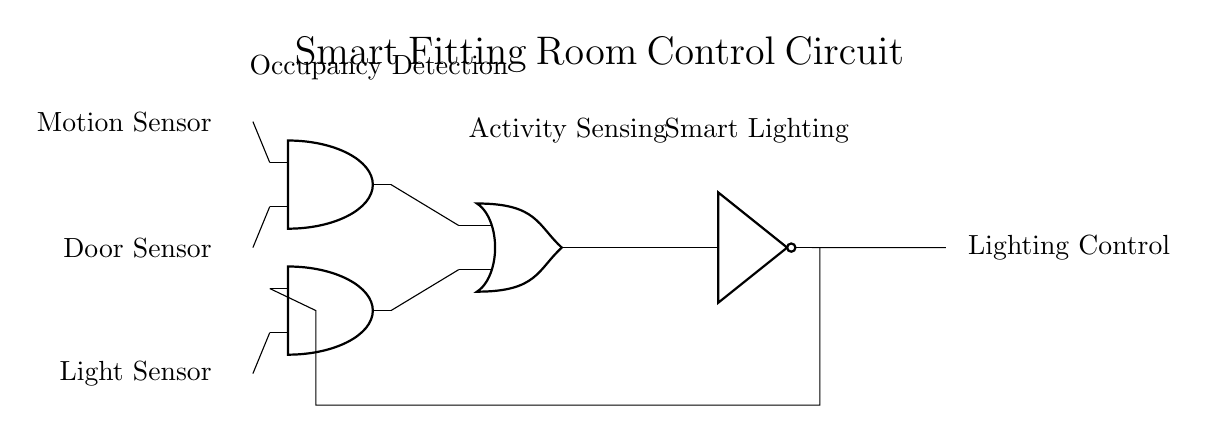What types of sensors are utilized in this circuit? The circuit uses three types of sensors: a motion sensor, a door sensor, and a light sensor, as indicated by their respective labels on the left side of the diagram.
Answer: motion sensor, door sensor, light sensor What component processes the signals from the motion and door sensors? The AND gate labeled as "Occupancy Detection" processes the inputs from both the motion sensor and the door sensor by combining their signals to determine if occupancy is detected.
Answer: AND gate How many AND gates are present in the circuit? There are two AND gates in the circuit, as seen in the diagram where both gates are indicated on different levels.
Answer: 2 Which sensor input controls the second AND gate? The second AND gate, labeled under "Activity Sensing," receives input from the light sensor exclusively, as indicated in the connection lines leading to it.
Answer: Light sensor What is the final output of the circuit? The output of the circuit, represented by the NOT gate, is connected to the lighting control mechanism, which is expressed at the far right of the diagram.
Answer: Lighting Control How does the feedback loop function in this circuit? The feedback loop connects from the output back to the input of the second AND gate, indicating that the circuit can regulate activity detection based on past light conditions, enhancing the overall responsive lighting control.
Answer: Regulates activity detection What logical operation does the circuit primarily perform to enhance customer experience? The circuit utilizes a combination of AND and OR operations to determine when to activate lighting based on sensor inputs, ensuring a responsive and pleasant fitting room experience for customers.
Answer: AND and OR operations 